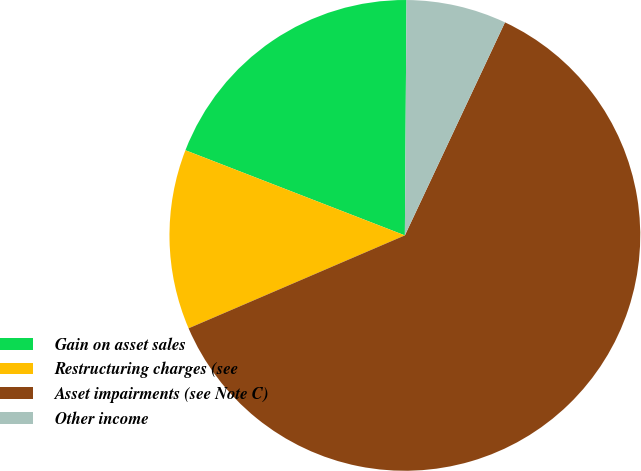Convert chart. <chart><loc_0><loc_0><loc_500><loc_500><pie_chart><fcel>Gain on asset sales<fcel>Restructuring charges (see<fcel>Asset impairments (see Note C)<fcel>Other income<nl><fcel>19.22%<fcel>12.35%<fcel>61.55%<fcel>6.88%<nl></chart> 